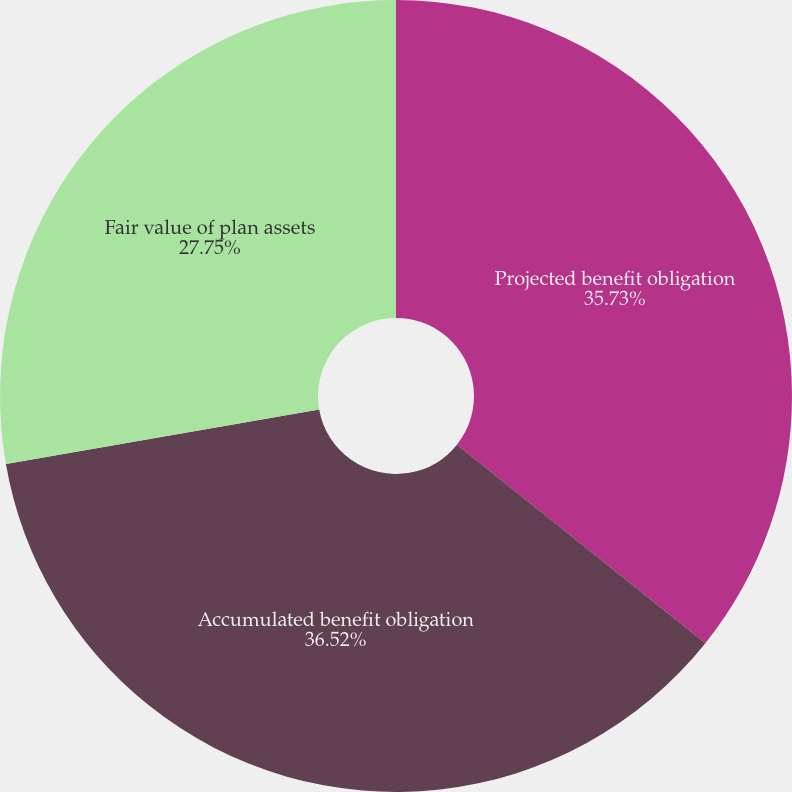Convert chart to OTSL. <chart><loc_0><loc_0><loc_500><loc_500><pie_chart><fcel>Projected benefit obligation<fcel>Accumulated benefit obligation<fcel>Fair value of plan assets<nl><fcel>35.73%<fcel>36.52%<fcel>27.75%<nl></chart> 